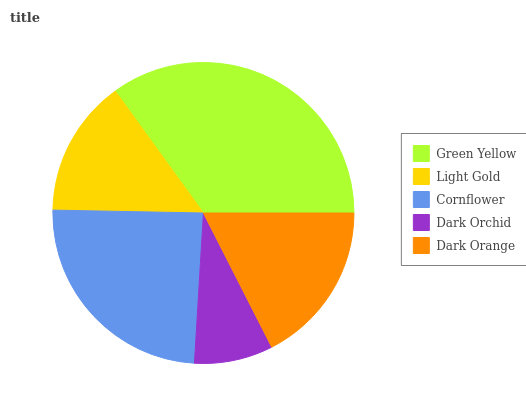Is Dark Orchid the minimum?
Answer yes or no. Yes. Is Green Yellow the maximum?
Answer yes or no. Yes. Is Light Gold the minimum?
Answer yes or no. No. Is Light Gold the maximum?
Answer yes or no. No. Is Green Yellow greater than Light Gold?
Answer yes or no. Yes. Is Light Gold less than Green Yellow?
Answer yes or no. Yes. Is Light Gold greater than Green Yellow?
Answer yes or no. No. Is Green Yellow less than Light Gold?
Answer yes or no. No. Is Dark Orange the high median?
Answer yes or no. Yes. Is Dark Orange the low median?
Answer yes or no. Yes. Is Light Gold the high median?
Answer yes or no. No. Is Green Yellow the low median?
Answer yes or no. No. 